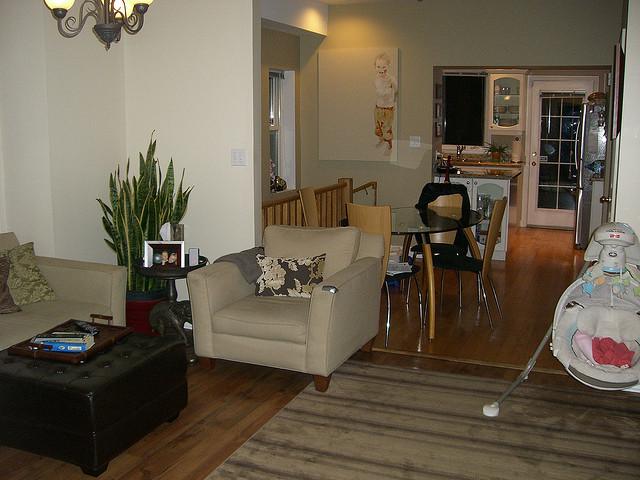Is this a bachelor pad or a family home?
Write a very short answer. Family home. What time of year is it?
Give a very brief answer. Winter. How many door knobs are visible?
Concise answer only. 1. Is there a baby in the swing?
Quick response, please. No. Is this an office?
Write a very short answer. No. What color are the flowers?
Write a very short answer. Green. Where is the kitchen?
Short answer required. In background. 